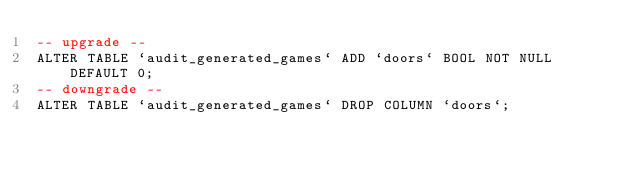<code> <loc_0><loc_0><loc_500><loc_500><_SQL_>-- upgrade --
ALTER TABLE `audit_generated_games` ADD `doors` BOOL NOT NULL  DEFAULT 0;
-- downgrade --
ALTER TABLE `audit_generated_games` DROP COLUMN `doors`;
</code> 